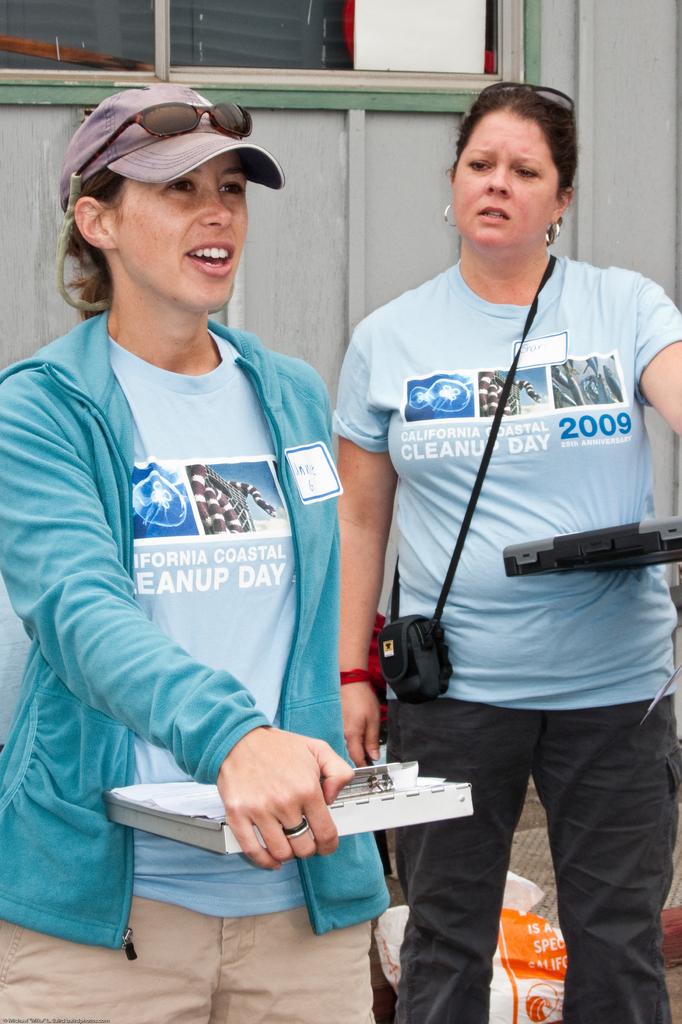What year is on her shirt?
Offer a very short reply. 2009. 